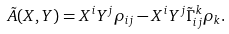Convert formula to latex. <formula><loc_0><loc_0><loc_500><loc_500>\tilde { A } ( X , Y ) = X ^ { i } Y ^ { j } \rho _ { i j } - X ^ { i } Y ^ { j } \tilde { \Gamma } _ { i j } ^ { k } \rho _ { k } .</formula> 